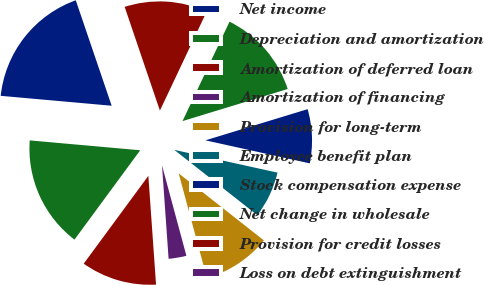Convert chart. <chart><loc_0><loc_0><loc_500><loc_500><pie_chart><fcel>Net income<fcel>Depreciation and amortization<fcel>Amortization of deferred loan<fcel>Amortization of financing<fcel>Provision for long-term<fcel>Employee benefit plan<fcel>Stock compensation expense<fcel>Net change in wholesale<fcel>Provision for credit losses<fcel>Loss on debt extinguishment<nl><fcel>18.36%<fcel>16.32%<fcel>11.22%<fcel>3.07%<fcel>10.2%<fcel>7.15%<fcel>8.17%<fcel>13.26%<fcel>12.24%<fcel>0.01%<nl></chart> 